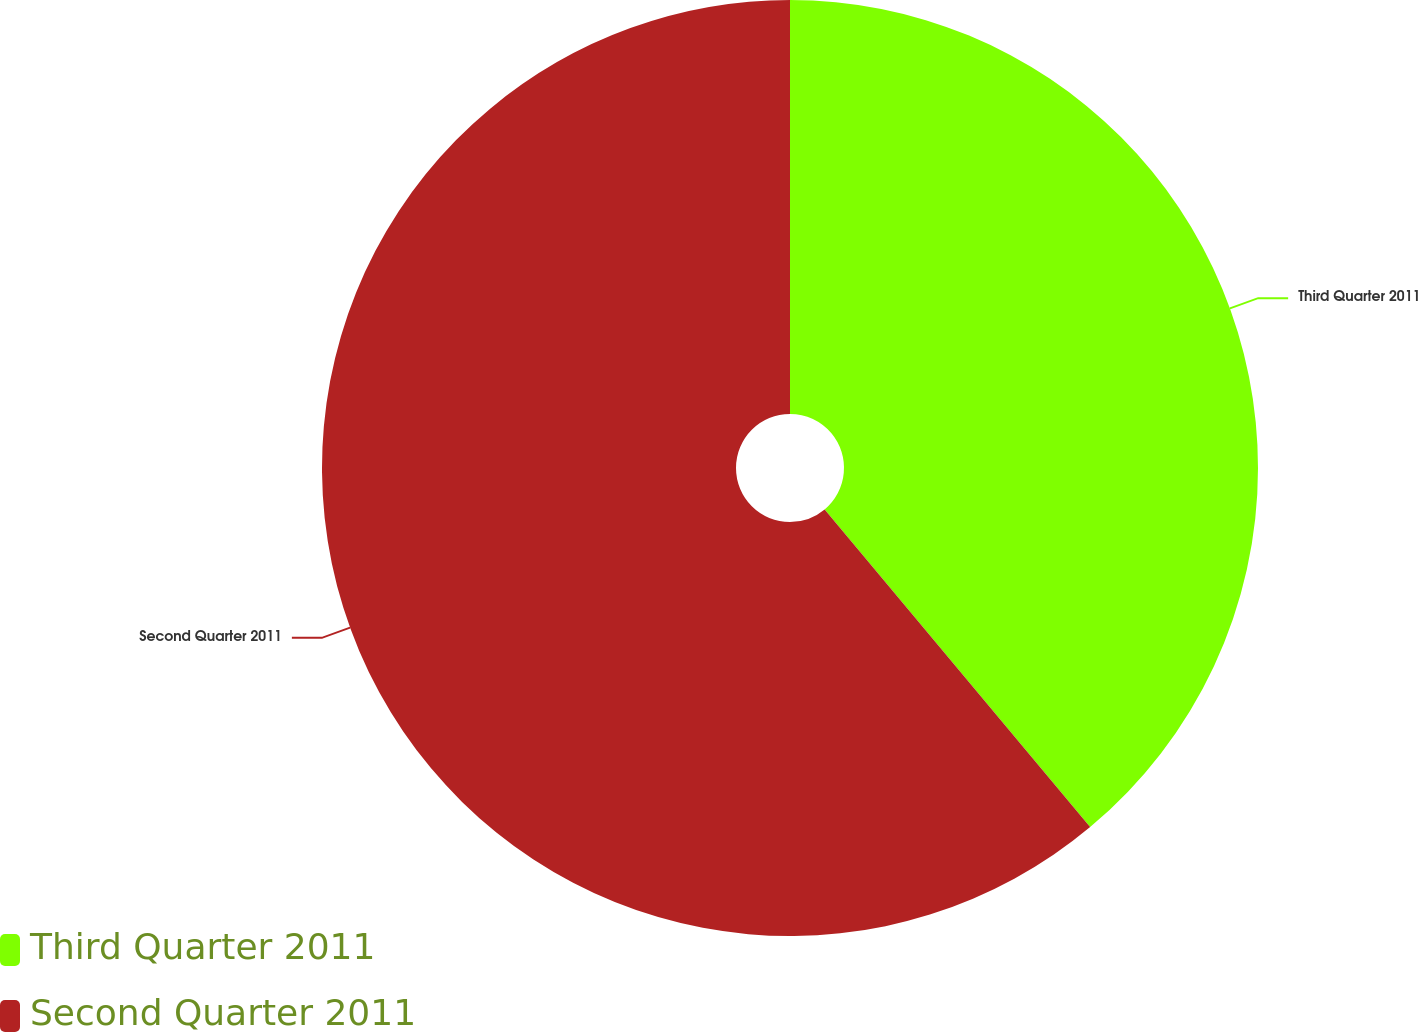<chart> <loc_0><loc_0><loc_500><loc_500><pie_chart><fcel>Third Quarter 2011<fcel>Second Quarter 2011<nl><fcel>38.92%<fcel>61.08%<nl></chart> 